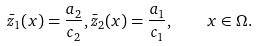Convert formula to latex. <formula><loc_0><loc_0><loc_500><loc_500>\bar { z } _ { 1 } ( x ) = \frac { a _ { 2 } } { c _ { 2 } } , \bar { z } _ { 2 } ( x ) = \frac { a _ { 1 } } { c _ { 1 } } , \quad x \in \Omega .</formula> 